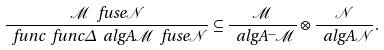Convert formula to latex. <formula><loc_0><loc_0><loc_500><loc_500>\frac { \mathcal { M } \ f u s e \mathcal { N } } { \ f u n c { \ f u n c { \Delta } { \ a l g { A } } } { \mathcal { M } \ f u s e \mathcal { N } } } \subseteq \frac { \mathcal { M } } { \ a l g { A } ^ { - } \mathcal { M } } \otimes \frac { \mathcal { N } } { \ a l g { A } \mathcal { N } } .</formula> 